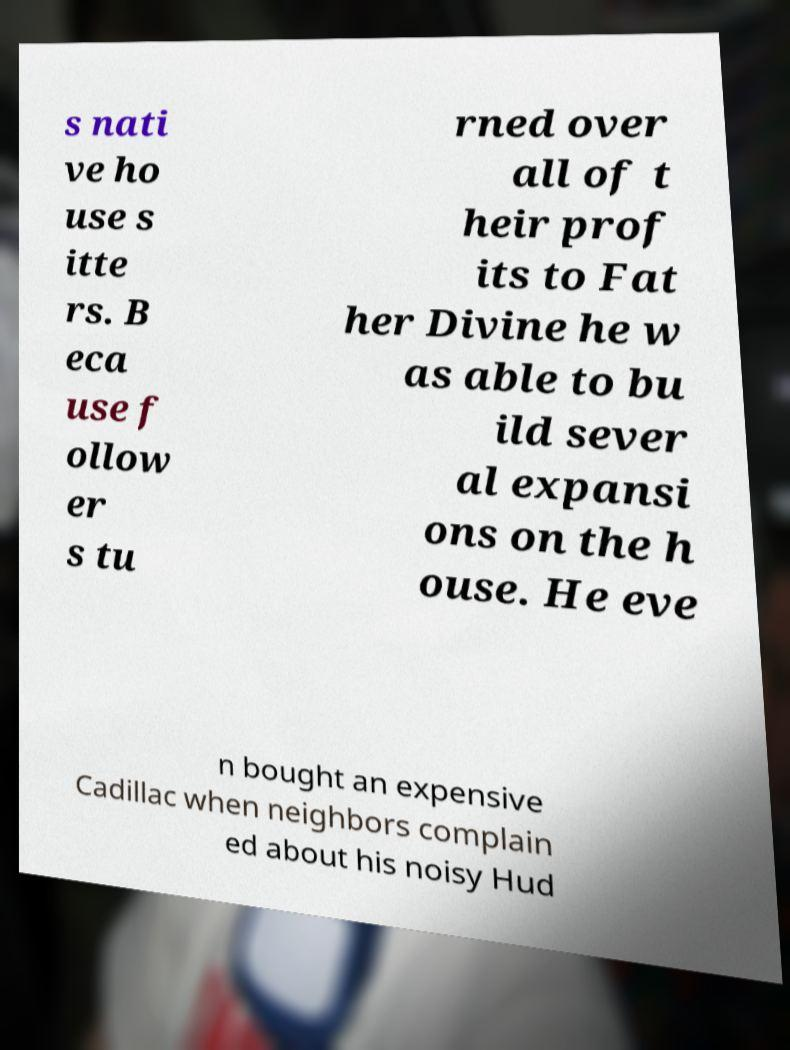For documentation purposes, I need the text within this image transcribed. Could you provide that? s nati ve ho use s itte rs. B eca use f ollow er s tu rned over all of t heir prof its to Fat her Divine he w as able to bu ild sever al expansi ons on the h ouse. He eve n bought an expensive Cadillac when neighbors complain ed about his noisy Hud 